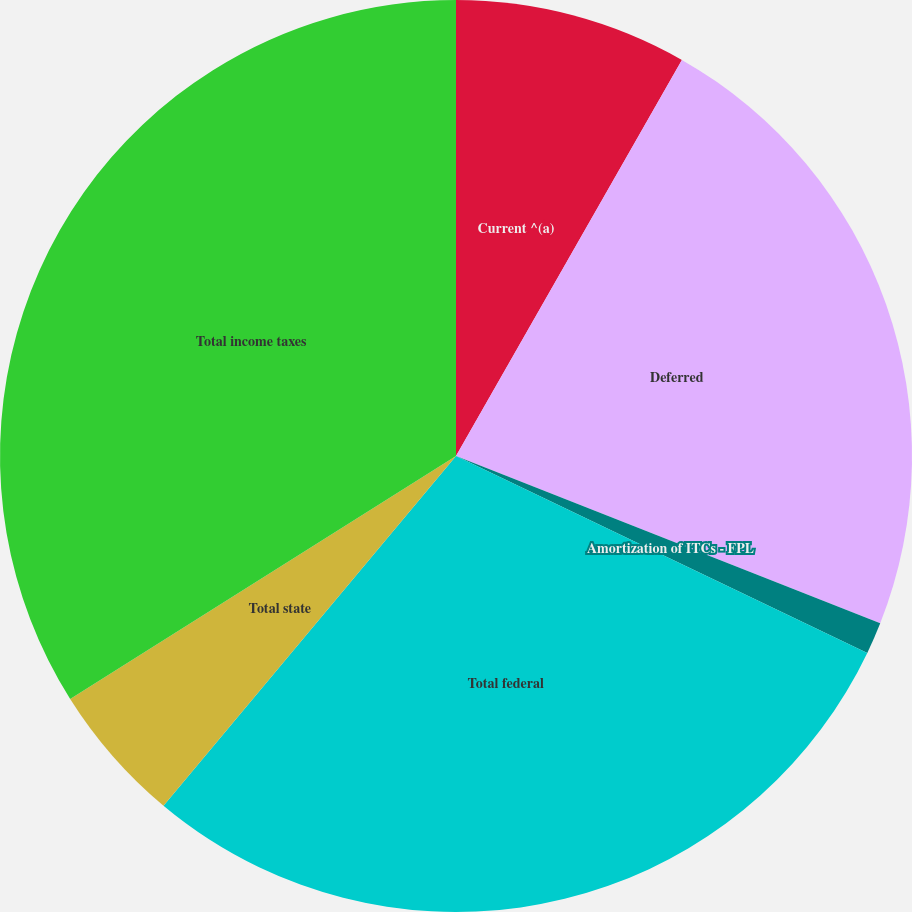Convert chart. <chart><loc_0><loc_0><loc_500><loc_500><pie_chart><fcel>Current ^(a)<fcel>Deferred<fcel>Amortization of ITCs - FPL<fcel>Total federal<fcel>Total state<fcel>Total income taxes<nl><fcel>8.25%<fcel>22.73%<fcel>1.13%<fcel>28.98%<fcel>4.97%<fcel>33.95%<nl></chart> 